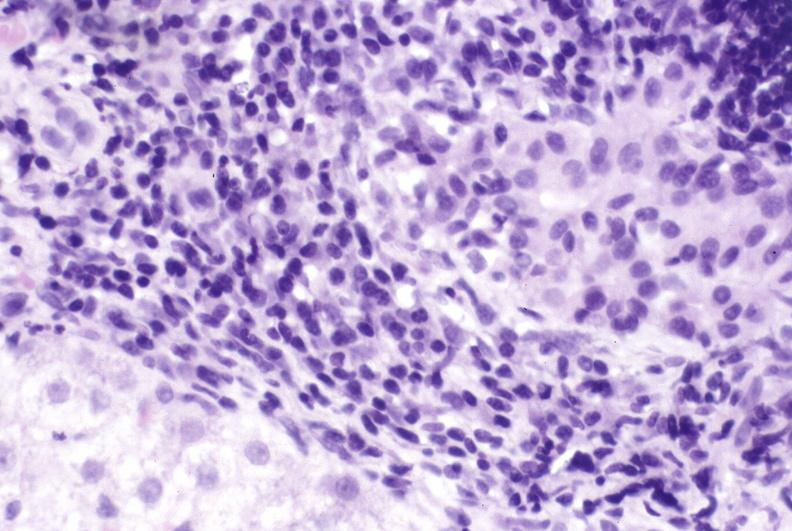s diagnosis present?
Answer the question using a single word or phrase. No 